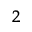Convert formula to latex. <formula><loc_0><loc_0><loc_500><loc_500>_ { 2 }</formula> 